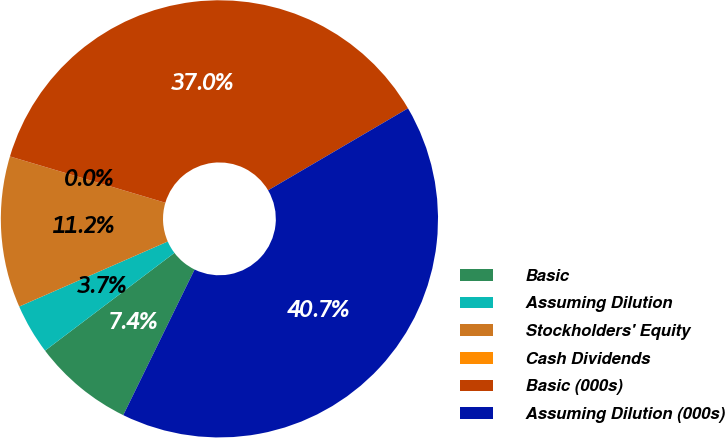Convert chart to OTSL. <chart><loc_0><loc_0><loc_500><loc_500><pie_chart><fcel>Basic<fcel>Assuming Dilution<fcel>Stockholders' Equity<fcel>Cash Dividends<fcel>Basic (000s)<fcel>Assuming Dilution (000s)<nl><fcel>7.45%<fcel>3.73%<fcel>11.18%<fcel>0.0%<fcel>36.96%<fcel>40.69%<nl></chart> 